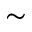<formula> <loc_0><loc_0><loc_500><loc_500>\sim</formula> 